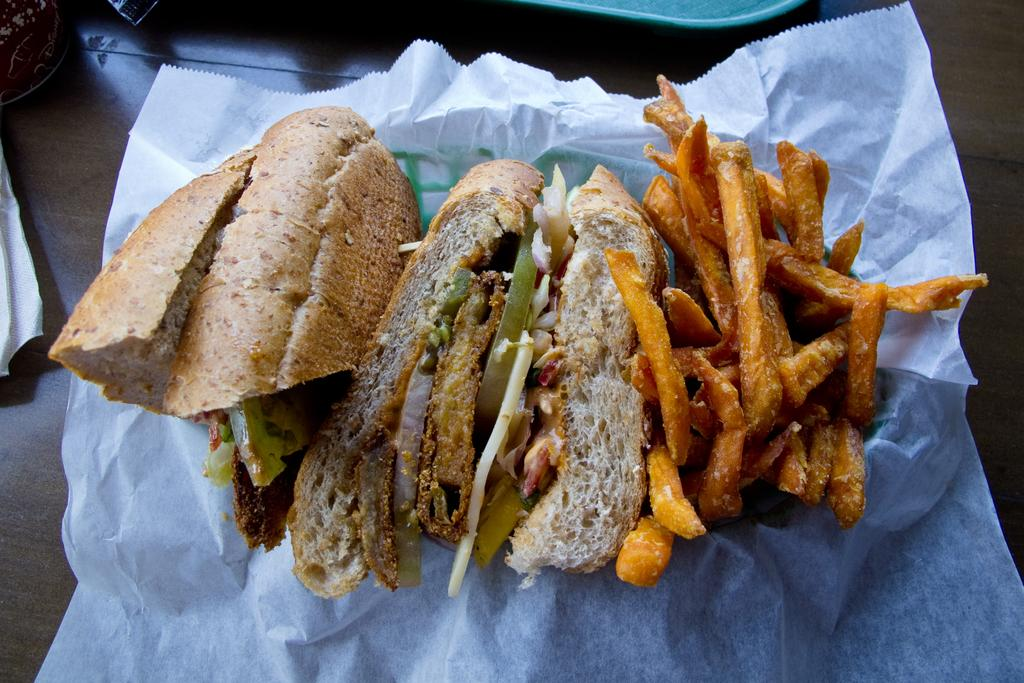What type of food is visible in the image? There is a sandwich and french fries in the image. How are the french fries wrapped in the image? The french fries are wrapped in a tissue. Where are the sandwich and french fries located in the image? They are on a table. What else can be seen on the table in the image? There is a tissue on the left side of the table. What is above the table in the image? There is a cloth above the table. What type of toothpaste is visible on the edge of the table in the image? There is no toothpaste present in the image. How is the oil being used in the image? There is no oil present in the image. 